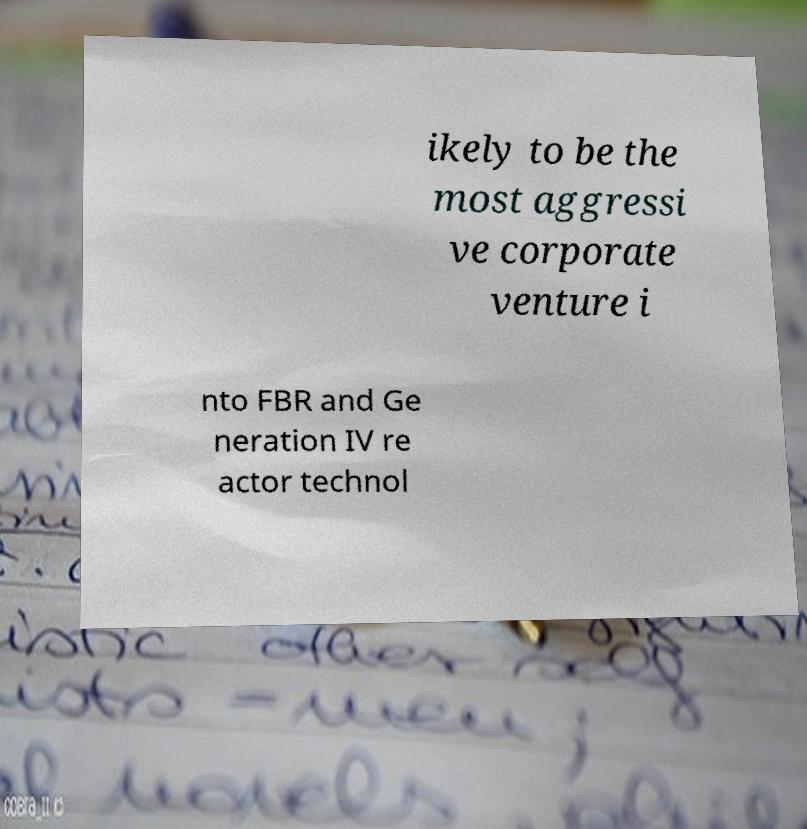Could you extract and type out the text from this image? ikely to be the most aggressi ve corporate venture i nto FBR and Ge neration IV re actor technol 